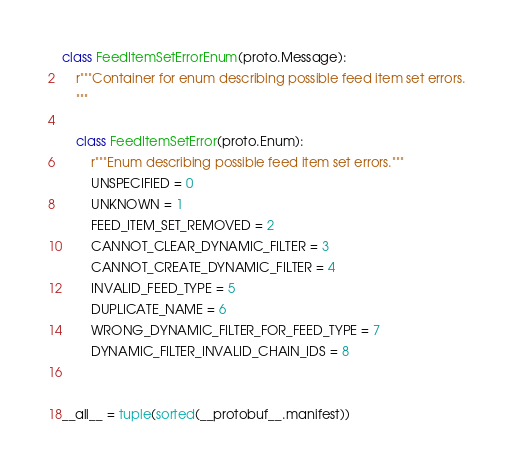Convert code to text. <code><loc_0><loc_0><loc_500><loc_500><_Python_>

class FeedItemSetErrorEnum(proto.Message):
    r"""Container for enum describing possible feed item set errors.
    """

    class FeedItemSetError(proto.Enum):
        r"""Enum describing possible feed item set errors."""
        UNSPECIFIED = 0
        UNKNOWN = 1
        FEED_ITEM_SET_REMOVED = 2
        CANNOT_CLEAR_DYNAMIC_FILTER = 3
        CANNOT_CREATE_DYNAMIC_FILTER = 4
        INVALID_FEED_TYPE = 5
        DUPLICATE_NAME = 6
        WRONG_DYNAMIC_FILTER_FOR_FEED_TYPE = 7
        DYNAMIC_FILTER_INVALID_CHAIN_IDS = 8


__all__ = tuple(sorted(__protobuf__.manifest))
</code> 